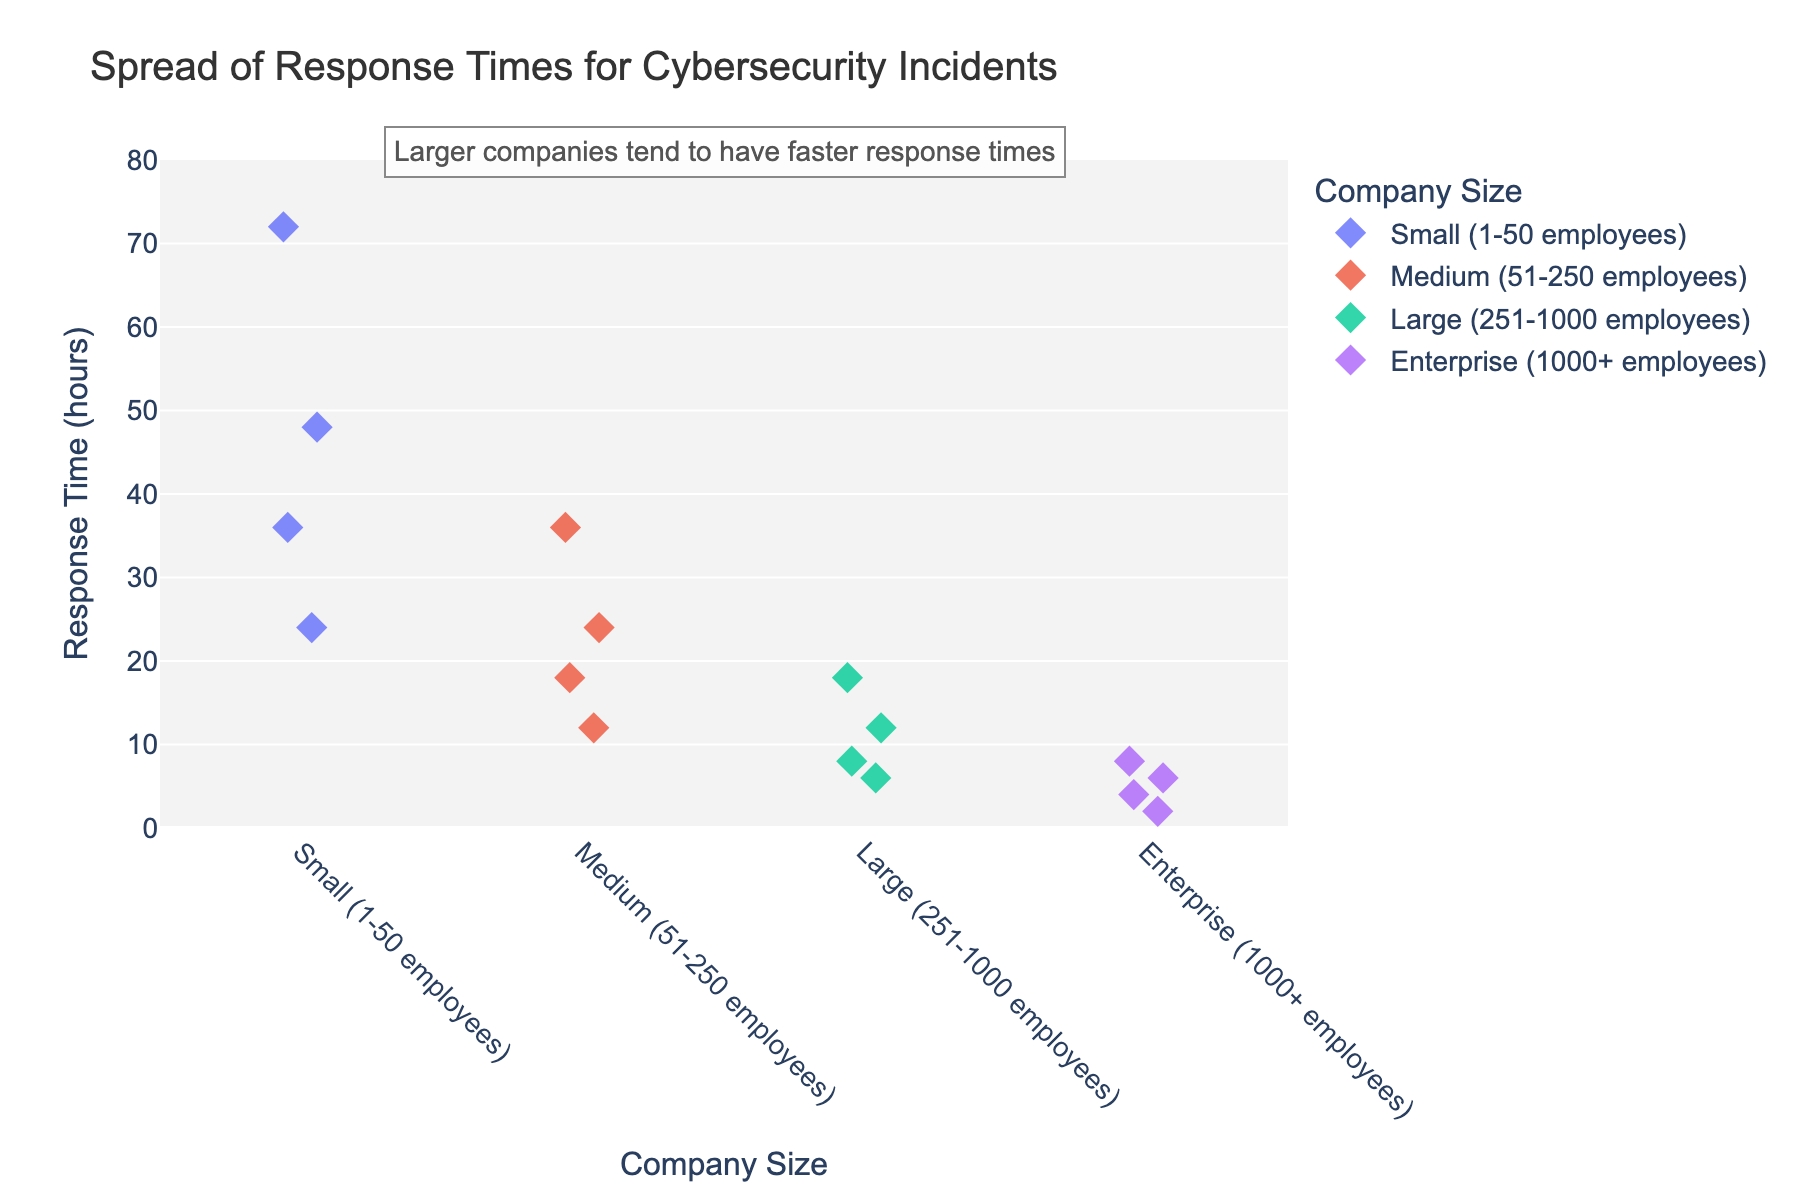What's the title of the plot? The title is displayed at the top of the figure, summarizing its content. It states "Spread of Response Times for Cybersecurity Incidents".
Answer: Spread of Response Times for Cybersecurity Incidents What are the four company size categories shown on the x-axis? The x-axis lists four different company sizes, which can be identified by reading the labels under the axis. They are: "Small (1-50 employees)", "Medium (51-250 employees)", "Large (251-1000 employees)", and "Enterprise (1000+ employees)".
Answer: Small (1-50 employees), Medium (51-250 employees), Large (251-1000 employees), Enterprise (1000+ employees) Which company size has the smallest response times? By examining the plot's y-axis values for each company size, we see that "Enterprise (1000+ employees)" has response times ranging from 2 to 8 hours, which are the smallest across groups.
Answer: Enterprise (1000+ employees) How many response time data points are there for Large (251-1000 employees)? The plot shows four markers (diamonds) for "Large (251-1000 employees)" on the x-axis. By counting these markers, we can determine there are 4 data points.
Answer: 4 What's the range of response times for Small (1-50 employees)? To determine the range, look at the highest and lowest response times for "Small (1-50 employees)" on the y-axis. The response times range from 24 to 72 hours.
Answer: 24 to 72 hours How does the median response time of Medium (51-250 employees) compare to Small (1-50 employees)? Calculate the median by finding the middle value in each sorted group. For Medium (51-250 employees), the response times are 12, 18, 24, and 36. The median is the average of 18 and 24, which is 21 hours. For Small (1-50 employees), times are 24, 36, 48, and 72. The median is the average of 36 and 48, which is 42 hours. The median for Medium (21 hours) is less than Small (42 hours).
Answer: Medium is less What trend is suggested by the annotation on the plot? The annotation hints at an overall trend in the data represented in the plot. It explicitly states, "Larger companies tend to have faster response times." This is observed as the response times decrease with the increase in company size categories.
Answer: Larger companies tend to have faster response times What's the difference in maximum response times between Large (251-1000 employees) and Enterprise (1000+ employees)? To find this, identify the maximum response times for both categories. For Large (251-1000 employees), the maximum is 18 hours. For Enterprise (1000+ employees), it is 8 hours. The difference is 18 - 8 = 10 hours.
Answer: 10 hours Which company size shows the most variability in response times? Variability can be assessed by looking at the spread of data points on the y-axis. "Small (1-50 employees)" has a wider spread from 24 to 72 hours, indicating the most variability.
Answer: Small (1-50 employees) Compare the fastest response time for Medium (51-250 employees) with the slowest response time for Enterprise (1000+ employees). The fastest time for Medium (51-250 employees) is the smallest y-value which is 12 hours, and the slowest for Enterprise (1000+ employees) is 8 hours. Thus, the fastest Medium response time (12) is more than the slowest Enterprise response time (8).
Answer: 12 hours is more than 8 hours 